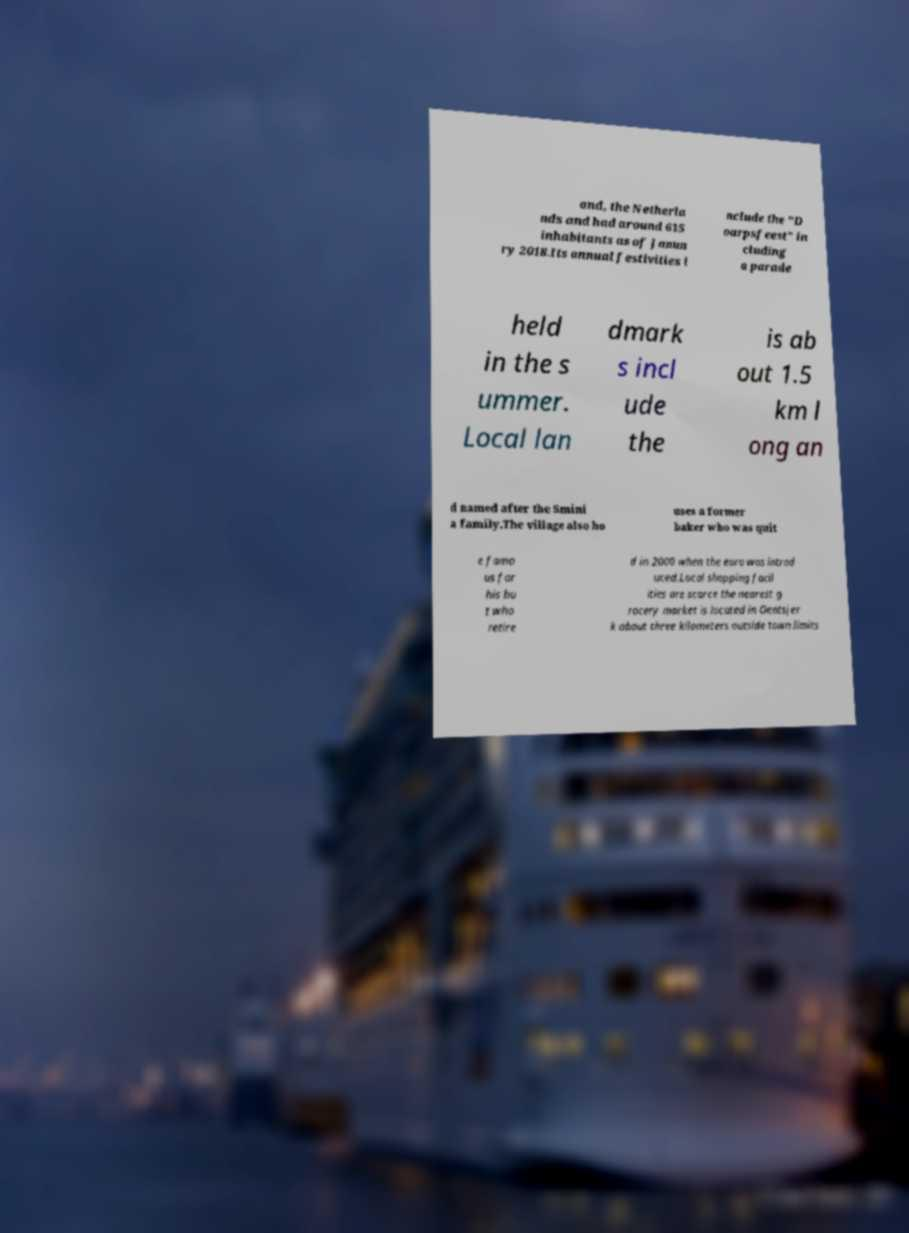Can you accurately transcribe the text from the provided image for me? and, the Netherla nds and had around 615 inhabitants as of Janua ry 2018.Its annual festivities i nclude the "D oarpsfeest" in cluding a parade held in the s ummer. Local lan dmark s incl ude the is ab out 1.5 km l ong an d named after the Smini a family.The village also ho uses a former baker who was quit e famo us for his bu t who retire d in 2000 when the euro was introd uced.Local shopping facil ities are scarce the nearest g rocery market is located in Oentsjer k about three kilometers outside town limits 